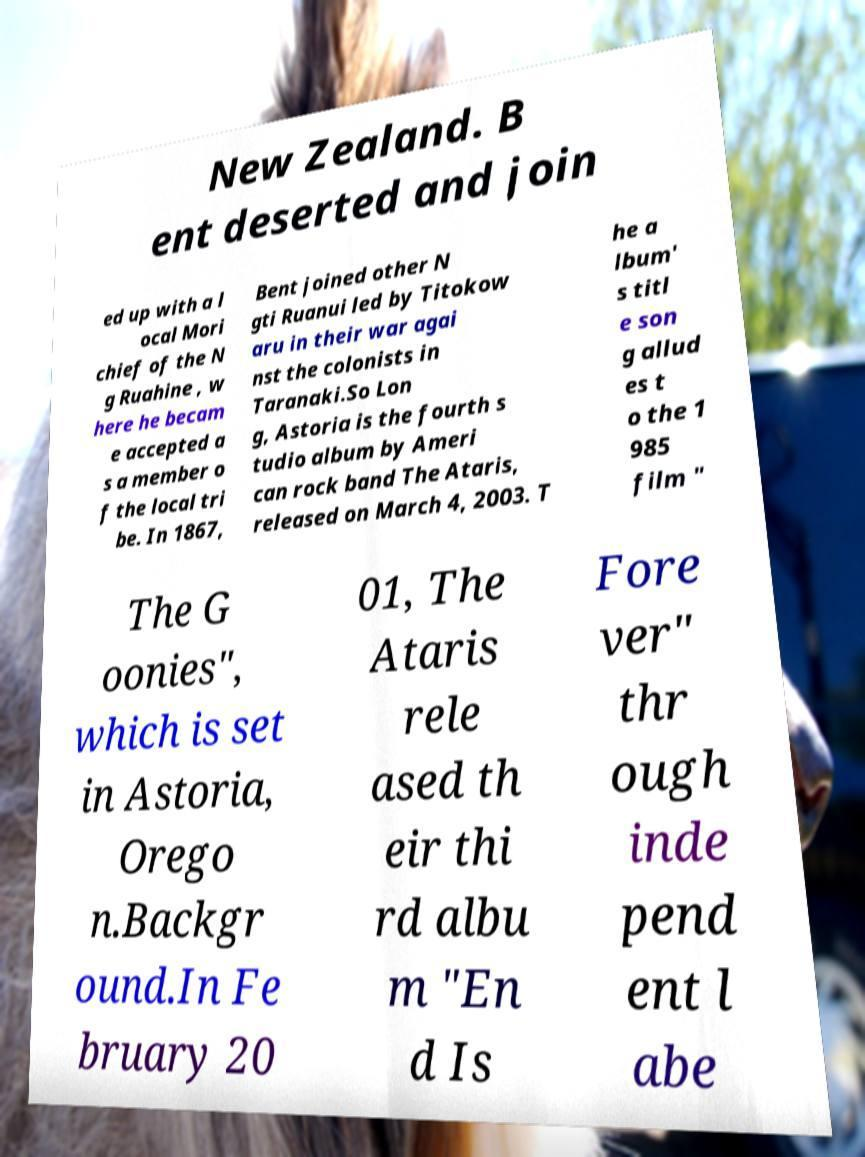What messages or text are displayed in this image? I need them in a readable, typed format. New Zealand. B ent deserted and join ed up with a l ocal Mori chief of the N g Ruahine , w here he becam e accepted a s a member o f the local tri be. In 1867, Bent joined other N gti Ruanui led by Titokow aru in their war agai nst the colonists in Taranaki.So Lon g, Astoria is the fourth s tudio album by Ameri can rock band The Ataris, released on March 4, 2003. T he a lbum' s titl e son g allud es t o the 1 985 film " The G oonies", which is set in Astoria, Orego n.Backgr ound.In Fe bruary 20 01, The Ataris rele ased th eir thi rd albu m "En d Is Fore ver" thr ough inde pend ent l abe 